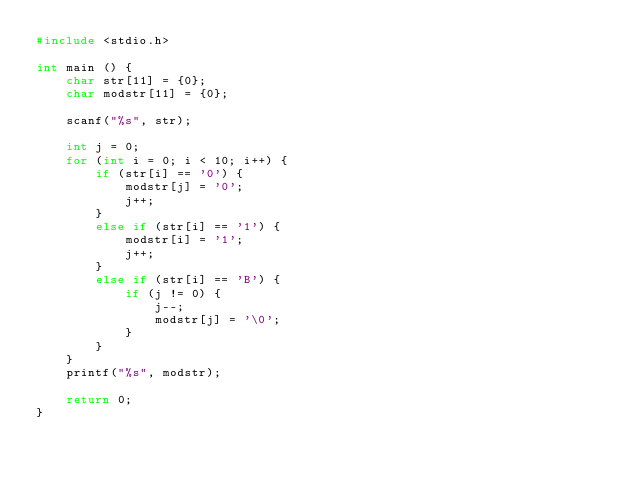Convert code to text. <code><loc_0><loc_0><loc_500><loc_500><_C_>#include <stdio.h>

int main () {
	char str[11] = {0};
	char modstr[11] = {0};
	
	scanf("%s", str);
	
	int j = 0;
	for (int i = 0; i < 10; i++) {
		if (str[i] == '0') {
			modstr[j] = '0';				
			j++;
		}
		else if (str[i] == '1') {
			modstr[i] = '1';
			j++; 
		}
		else if (str[i] == 'B') {
			if (j != 0) {
				j--;
				modstr[j] = '\0';
			}
		}
	}
	printf("%s", modstr);
	
	return 0;
}</code> 